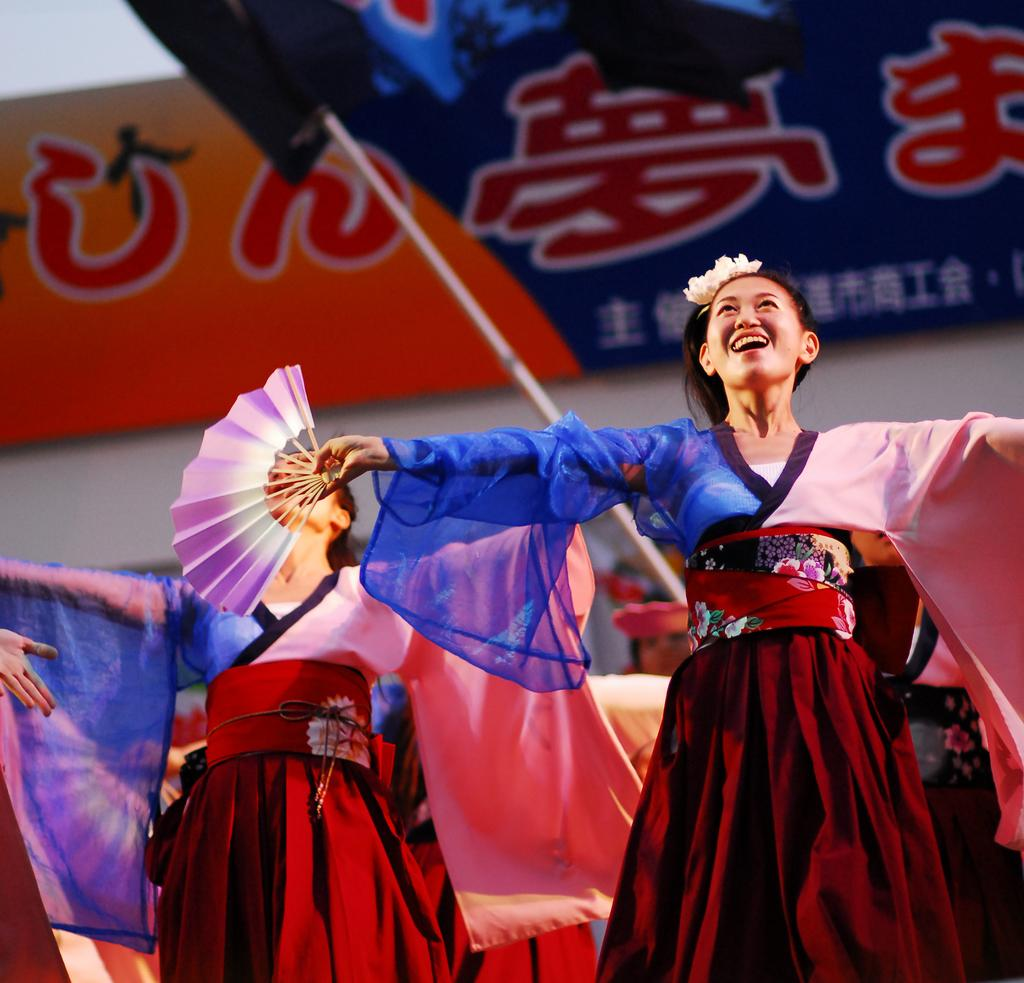What can be seen in the image? There are groups of women in the image. What are the women wearing? The women are wearing costumes. Can you describe any specific accessory one of the women is holding? One woman is holding a hand fan. What is visible in the background of the image? There is a tent and a sign board with text in the background of the image. Where is the library located in the image? There is no library present in the image. What action are the women performing in the image? The image does not show any specific action being performed by the women; they are simply standing or posing. 